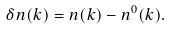<formula> <loc_0><loc_0><loc_500><loc_500>\delta n ( { k } ) = n ( { k } ) - n ^ { 0 } ( { k } ) .</formula> 